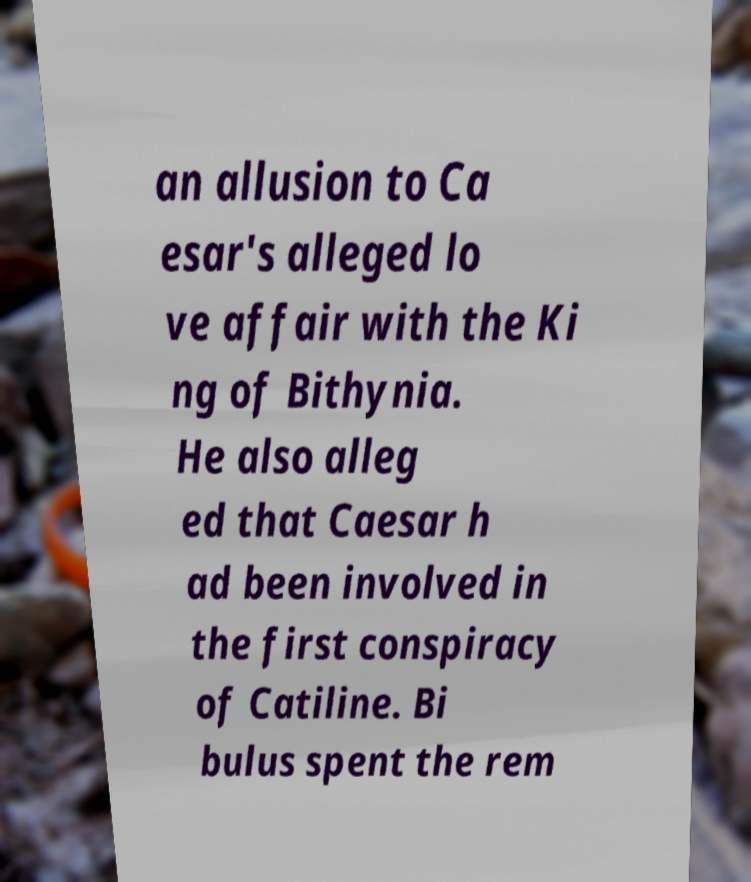Please identify and transcribe the text found in this image. an allusion to Ca esar's alleged lo ve affair with the Ki ng of Bithynia. He also alleg ed that Caesar h ad been involved in the first conspiracy of Catiline. Bi bulus spent the rem 